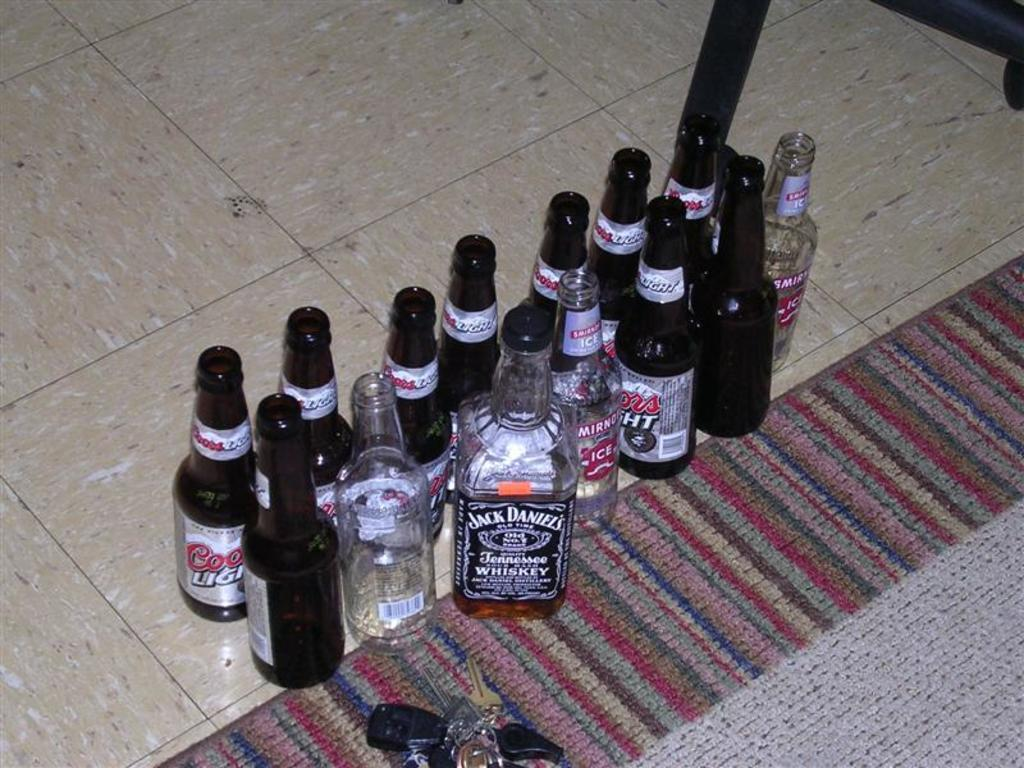Provide a one-sentence caption for the provided image. A half-full Jack Daniels bottle stands tall amongst some Coors Light bottles, Smirnoff Ice bottles, and car keys. 